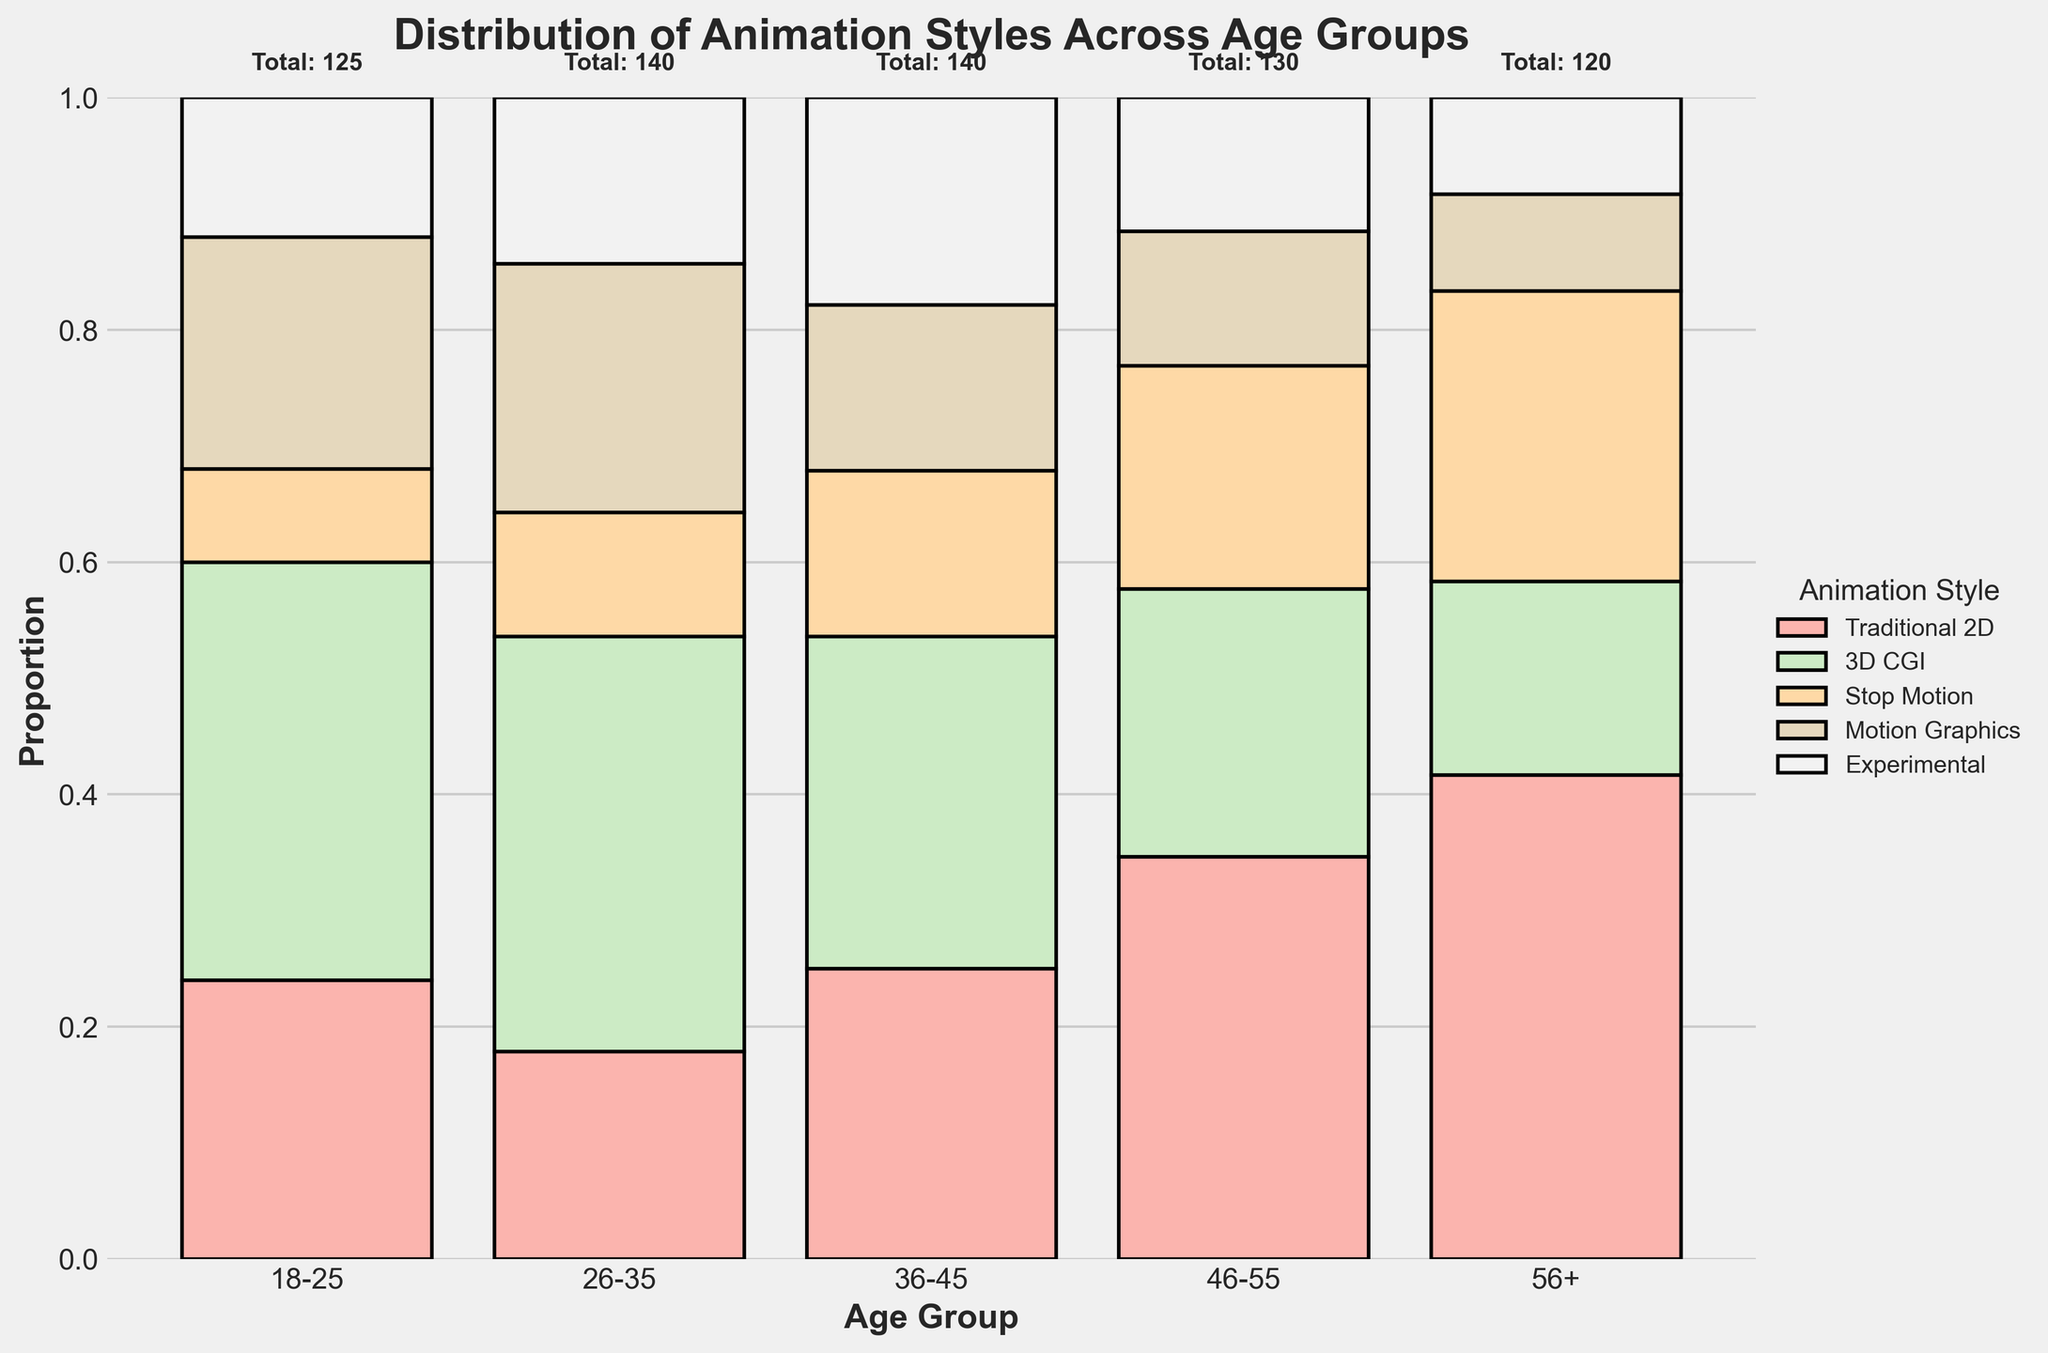What is the title of the plot? The title is found at the top of the plot. It provides an overview of what the plot represents.
Answer: Distribution of Animation Styles Across Age Groups How many age groups are represented in the plot? The number of age groups can be determined by counting the distinct age group labels on the x-axis of the plot.
Answer: 5 Which age group has the highest total count of animators? Each age group has a total count annotated above the bars. Compare these totals to find the highest.
Answer: 56+ What is the proportion of Traditional 2D animators in the 46-55 age group? Find the bar corresponding to Traditional 2D for the 46-55 age group. The height of this segment over the total height (1.0) gives the proportion.
Answer: 45 / 130 (approximately 34.6%) Which animation style is least common among animators aged 26-35? Observe the size of the segments for the 26-35 age group's bar; the shortest bar segment represents the least common style.
Answer: Traditional 2D Between the 18-25 and 26-35 age groups, which group has a higher proportion of 3D CGI animators? Compare the height of the 3D CGI segments in the bars for both age groups.
Answer: 26-35 What is the total number of animators across all age groups? Sum the total counts annotated above the bars for each age group.
Answer: 500 In the 36-45 age group, which two animation styles have the same number of animators? Identify segments of equal height within the 36-45 age group's bar.
Answer: Traditional 2D and Experimental Comparing the 46-55 and 56+ age groups, which group has a higher number of Experimental animators? Look at the height of the Experimental segment for both age groups and compare their count.
Answer: 36-45 